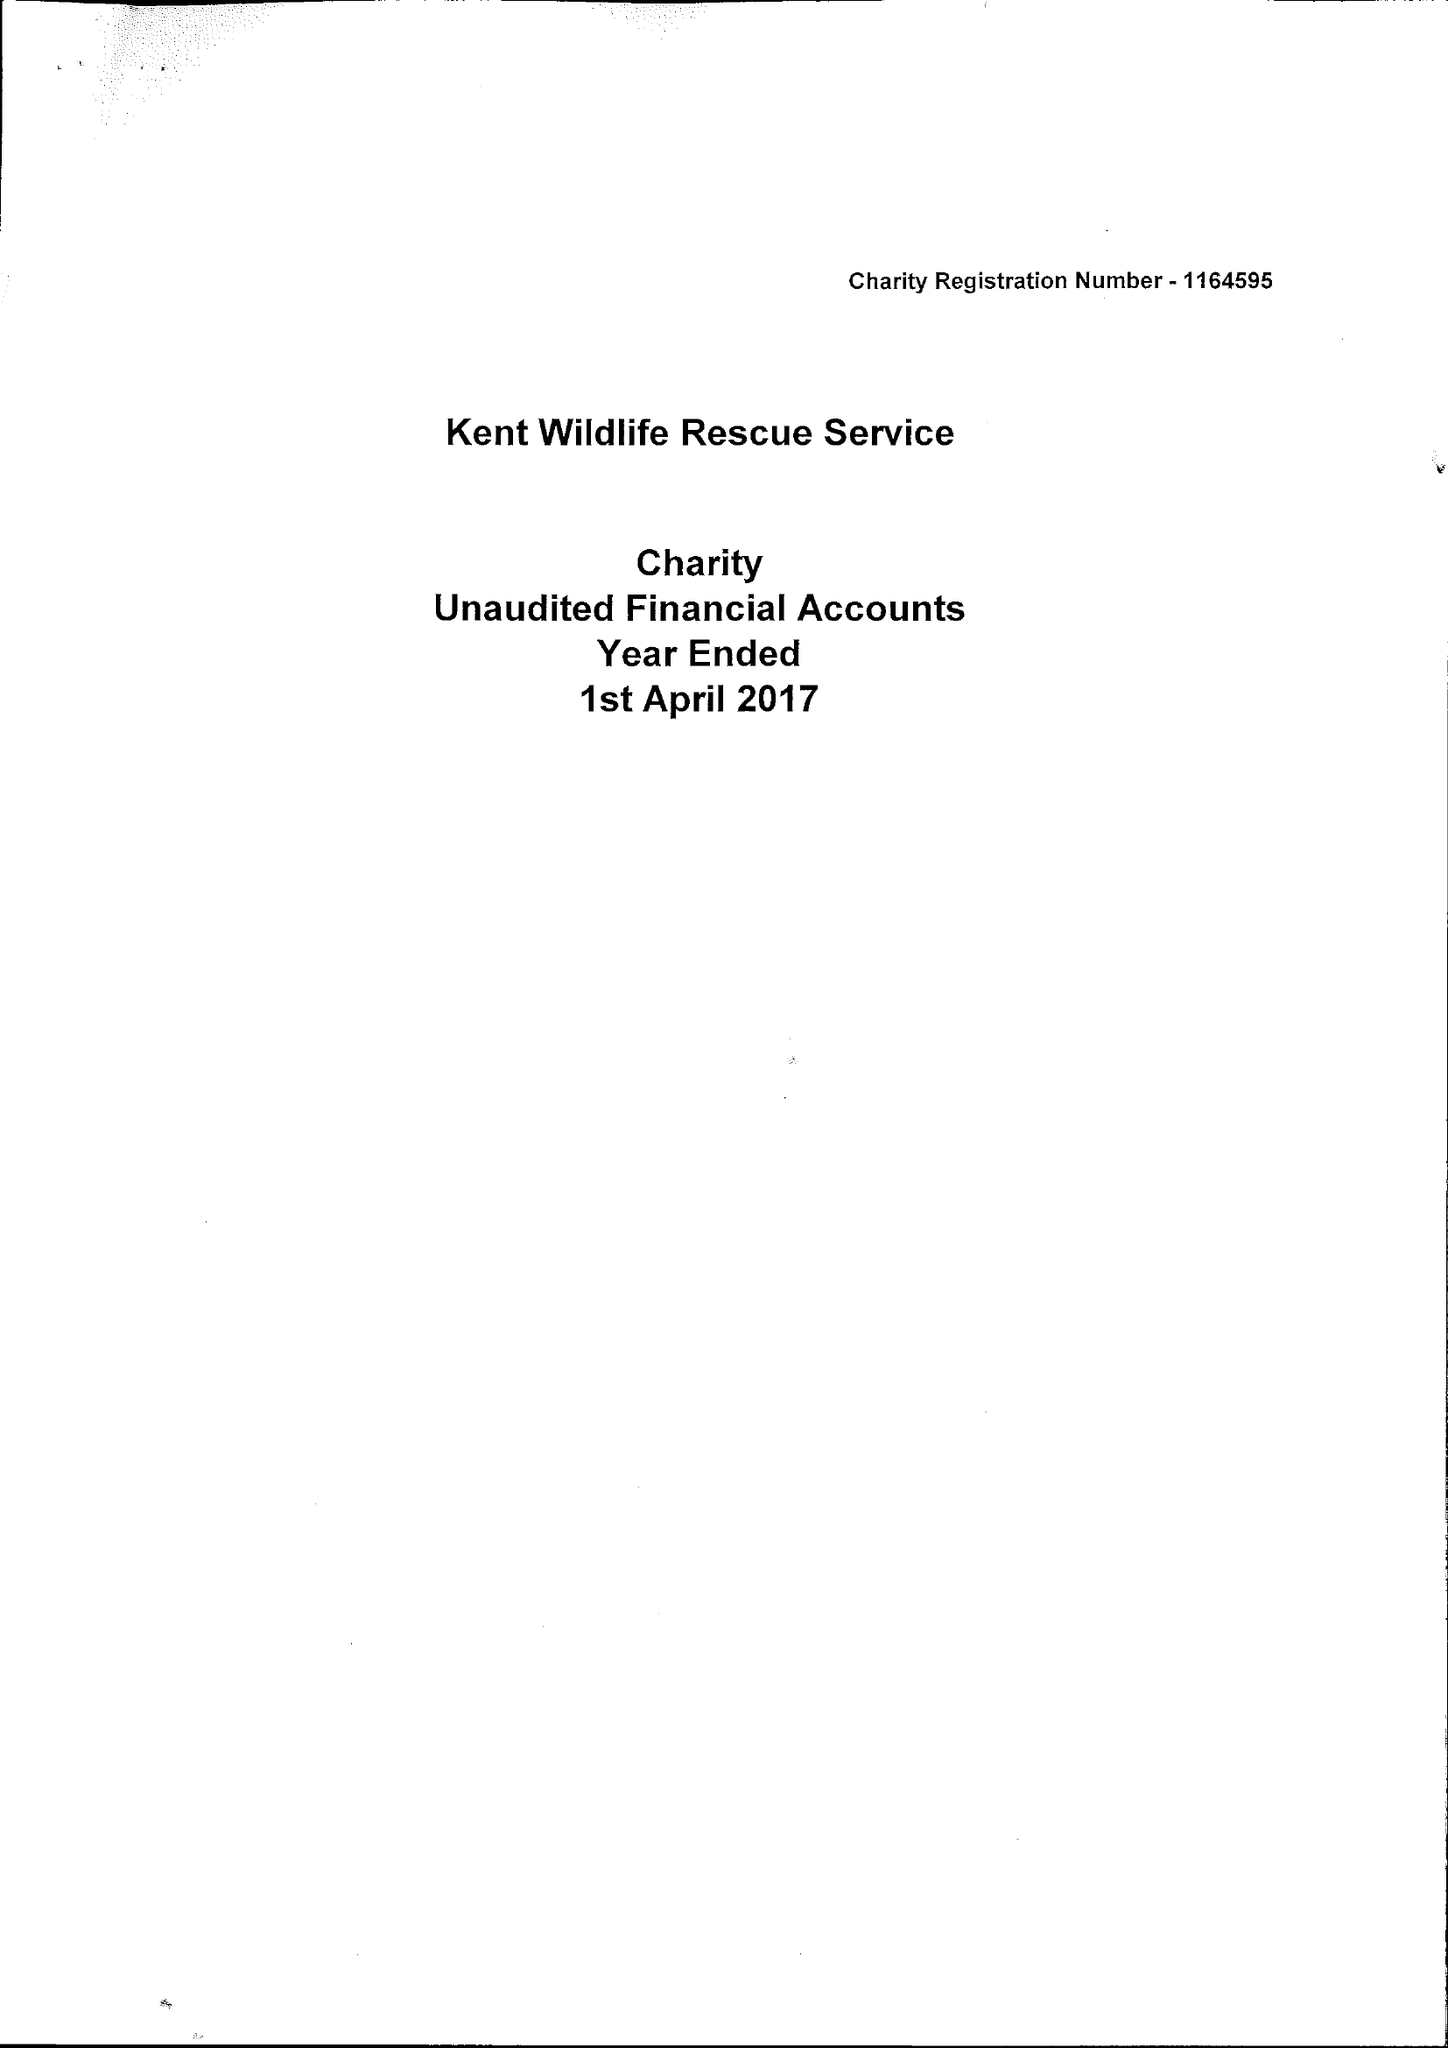What is the value for the address__post_town?
Answer the question using a single word or phrase. SHEERNESS 